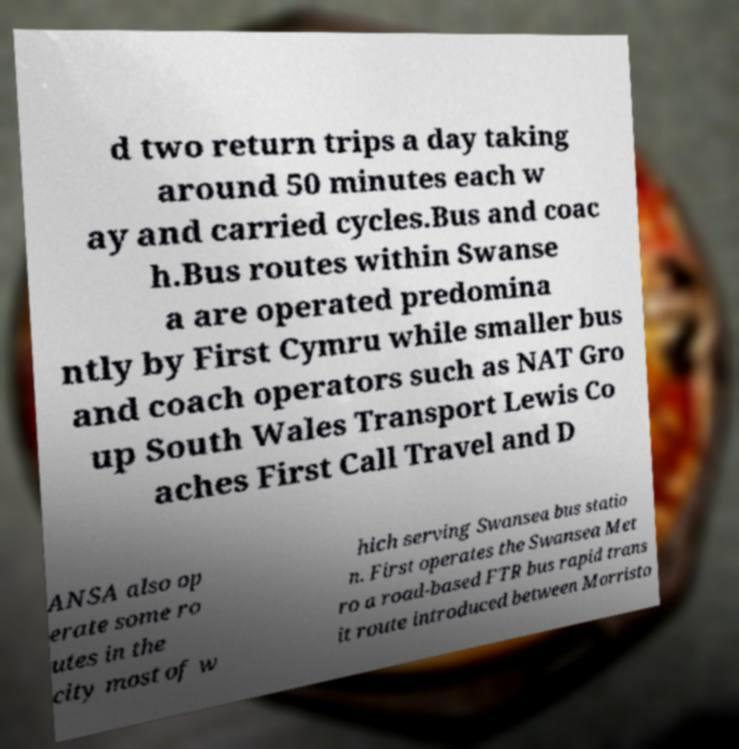There's text embedded in this image that I need extracted. Can you transcribe it verbatim? d two return trips a day taking around 50 minutes each w ay and carried cycles.Bus and coac h.Bus routes within Swanse a are operated predomina ntly by First Cymru while smaller bus and coach operators such as NAT Gro up South Wales Transport Lewis Co aches First Call Travel and D ANSA also op erate some ro utes in the city most of w hich serving Swansea bus statio n. First operates the Swansea Met ro a road-based FTR bus rapid trans it route introduced between Morristo 